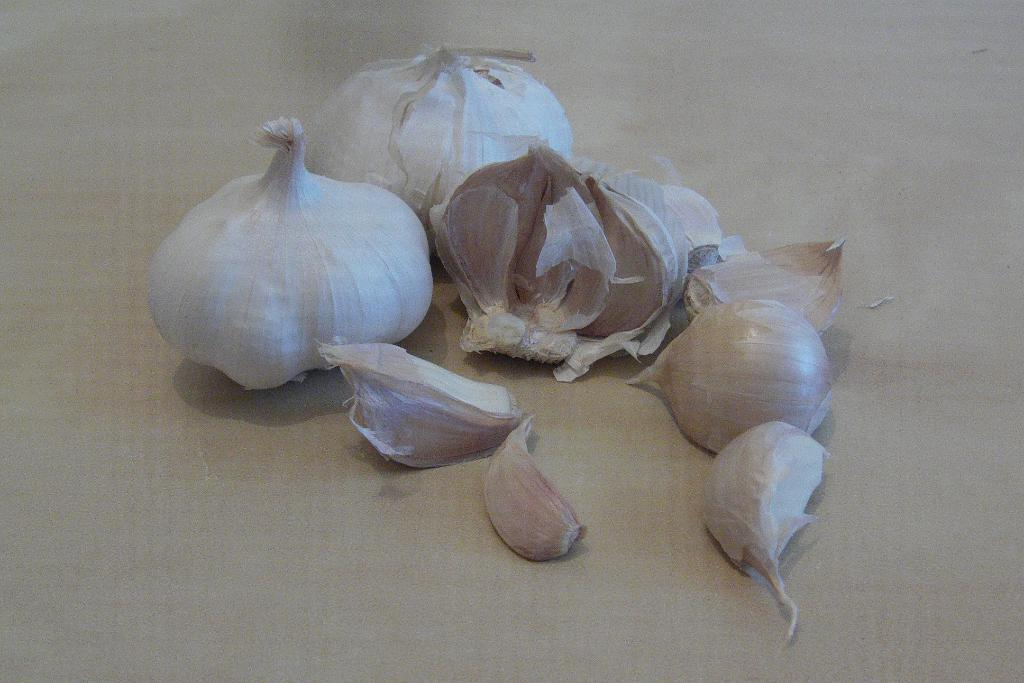What is on the floor in the image? There are garlic cloves on the floor. What type of organization is represented by the garlic cloves on the floor? The garlic cloves on the floor do not represent any type of organization; they are simply garlic cloves. How many rays can be seen emanating from the garlic cloves in the image? There are no rays visible in the image, as it features garlic cloves on the floor. 